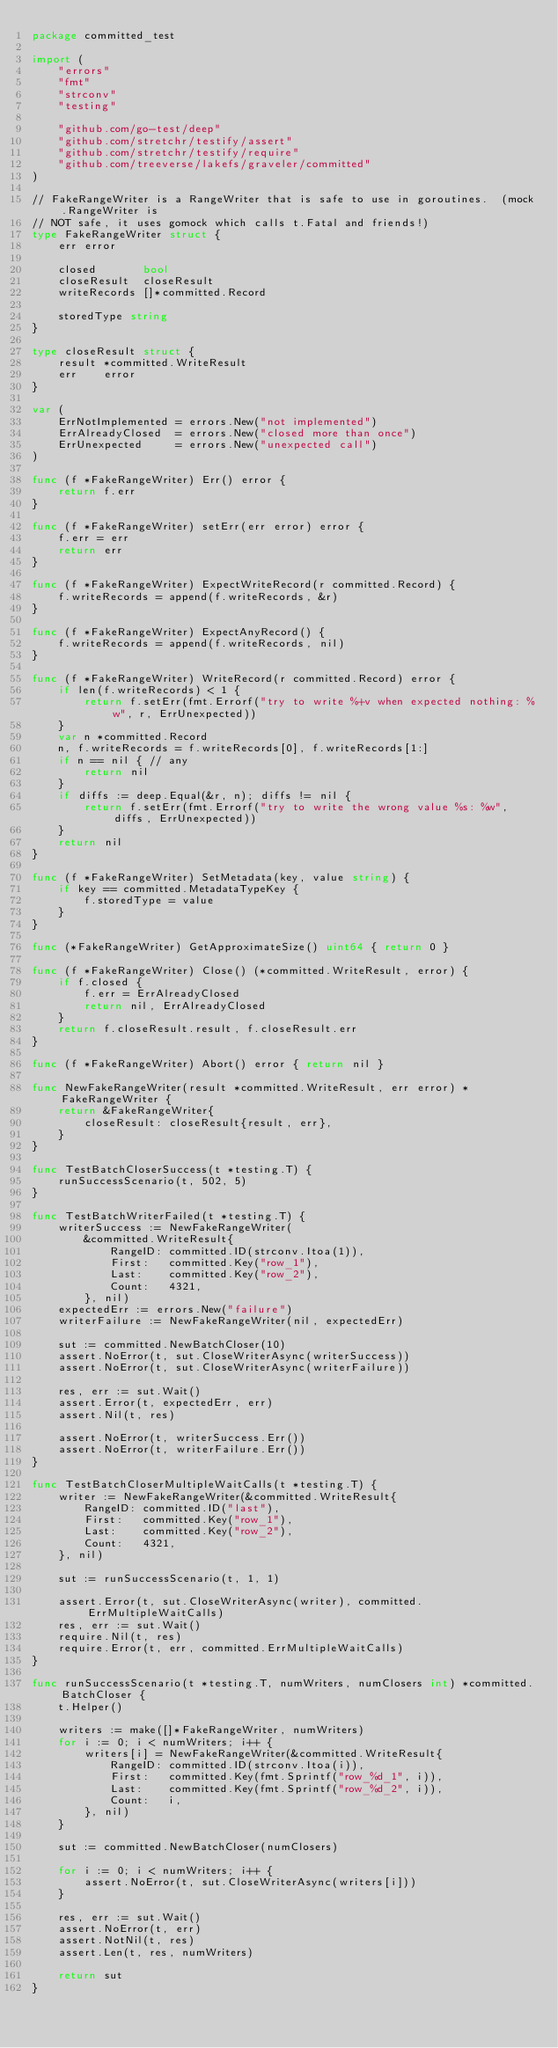<code> <loc_0><loc_0><loc_500><loc_500><_Go_>package committed_test

import (
	"errors"
	"fmt"
	"strconv"
	"testing"

	"github.com/go-test/deep"
	"github.com/stretchr/testify/assert"
	"github.com/stretchr/testify/require"
	"github.com/treeverse/lakefs/graveler/committed"
)

// FakeRangeWriter is a RangeWriter that is safe to use in goroutines.  (mock.RangeWriter is
// NOT safe, it uses gomock which calls t.Fatal and friends!)
type FakeRangeWriter struct {
	err error

	closed       bool
	closeResult  closeResult
	writeRecords []*committed.Record

	storedType string
}

type closeResult struct {
	result *committed.WriteResult
	err    error
}

var (
	ErrNotImplemented = errors.New("not implemented")
	ErrAlreadyClosed  = errors.New("closed more than once")
	ErrUnexpected     = errors.New("unexpected call")
)

func (f *FakeRangeWriter) Err() error {
	return f.err
}

func (f *FakeRangeWriter) setErr(err error) error {
	f.err = err
	return err
}

func (f *FakeRangeWriter) ExpectWriteRecord(r committed.Record) {
	f.writeRecords = append(f.writeRecords, &r)
}

func (f *FakeRangeWriter) ExpectAnyRecord() {
	f.writeRecords = append(f.writeRecords, nil)
}

func (f *FakeRangeWriter) WriteRecord(r committed.Record) error {
	if len(f.writeRecords) < 1 {
		return f.setErr(fmt.Errorf("try to write %+v when expected nothing: %w", r, ErrUnexpected))
	}
	var n *committed.Record
	n, f.writeRecords = f.writeRecords[0], f.writeRecords[1:]
	if n == nil { // any
		return nil
	}
	if diffs := deep.Equal(&r, n); diffs != nil {
		return f.setErr(fmt.Errorf("try to write the wrong value %s: %w", diffs, ErrUnexpected))
	}
	return nil
}

func (f *FakeRangeWriter) SetMetadata(key, value string) {
	if key == committed.MetadataTypeKey {
		f.storedType = value
	}
}

func (*FakeRangeWriter) GetApproximateSize() uint64 { return 0 }

func (f *FakeRangeWriter) Close() (*committed.WriteResult, error) {
	if f.closed {
		f.err = ErrAlreadyClosed
		return nil, ErrAlreadyClosed
	}
	return f.closeResult.result, f.closeResult.err
}

func (f *FakeRangeWriter) Abort() error { return nil }

func NewFakeRangeWriter(result *committed.WriteResult, err error) *FakeRangeWriter {
	return &FakeRangeWriter{
		closeResult: closeResult{result, err},
	}
}

func TestBatchCloserSuccess(t *testing.T) {
	runSuccessScenario(t, 502, 5)
}

func TestBatchWriterFailed(t *testing.T) {
	writerSuccess := NewFakeRangeWriter(
		&committed.WriteResult{
			RangeID: committed.ID(strconv.Itoa(1)),
			First:   committed.Key("row_1"),
			Last:    committed.Key("row_2"),
			Count:   4321,
		}, nil)
	expectedErr := errors.New("failure")
	writerFailure := NewFakeRangeWriter(nil, expectedErr)

	sut := committed.NewBatchCloser(10)
	assert.NoError(t, sut.CloseWriterAsync(writerSuccess))
	assert.NoError(t, sut.CloseWriterAsync(writerFailure))

	res, err := sut.Wait()
	assert.Error(t, expectedErr, err)
	assert.Nil(t, res)

	assert.NoError(t, writerSuccess.Err())
	assert.NoError(t, writerFailure.Err())
}

func TestBatchCloserMultipleWaitCalls(t *testing.T) {
	writer := NewFakeRangeWriter(&committed.WriteResult{
		RangeID: committed.ID("last"),
		First:   committed.Key("row_1"),
		Last:    committed.Key("row_2"),
		Count:   4321,
	}, nil)

	sut := runSuccessScenario(t, 1, 1)

	assert.Error(t, sut.CloseWriterAsync(writer), committed.ErrMultipleWaitCalls)
	res, err := sut.Wait()
	require.Nil(t, res)
	require.Error(t, err, committed.ErrMultipleWaitCalls)
}

func runSuccessScenario(t *testing.T, numWriters, numClosers int) *committed.BatchCloser {
	t.Helper()

	writers := make([]*FakeRangeWriter, numWriters)
	for i := 0; i < numWriters; i++ {
		writers[i] = NewFakeRangeWriter(&committed.WriteResult{
			RangeID: committed.ID(strconv.Itoa(i)),
			First:   committed.Key(fmt.Sprintf("row_%d_1", i)),
			Last:    committed.Key(fmt.Sprintf("row_%d_2", i)),
			Count:   i,
		}, nil)
	}

	sut := committed.NewBatchCloser(numClosers)

	for i := 0; i < numWriters; i++ {
		assert.NoError(t, sut.CloseWriterAsync(writers[i]))
	}

	res, err := sut.Wait()
	assert.NoError(t, err)
	assert.NotNil(t, res)
	assert.Len(t, res, numWriters)

	return sut
}
</code> 